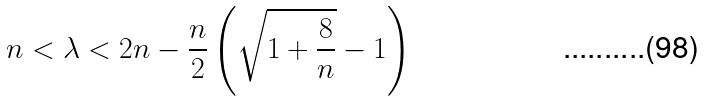<formula> <loc_0><loc_0><loc_500><loc_500>n < \lambda < 2 n - \frac { n } { 2 } \left ( \sqrt { 1 + \frac { 8 } { n } } - 1 \right )</formula> 